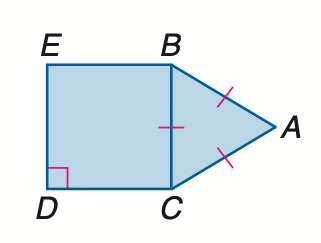Question: Find the ratio of the area of \triangle A B C to the area of square B C D E.
Choices:
A. 1 : 3
B. \frac { \sqrt 3 } { 4 } : 1
C. \frac { \sqrt 3 } { 2 } : 1
D. \sqrt { 3 } :1
Answer with the letter. Answer: B 